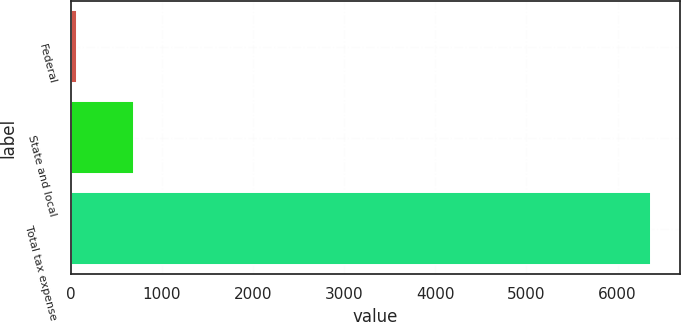Convert chart. <chart><loc_0><loc_0><loc_500><loc_500><bar_chart><fcel>Federal<fcel>State and local<fcel>Total tax expense<nl><fcel>66<fcel>696<fcel>6366<nl></chart> 